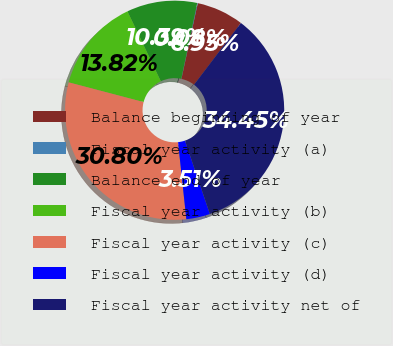Convert chart to OTSL. <chart><loc_0><loc_0><loc_500><loc_500><pie_chart><fcel>Balance beginning of year<fcel>Fiscal year activity (a)<fcel>Balance end of year<fcel>Fiscal year activity (b)<fcel>Fiscal year activity (c)<fcel>Fiscal year activity (d)<fcel>Fiscal year activity net of<nl><fcel>6.95%<fcel>0.08%<fcel>10.39%<fcel>13.82%<fcel>30.8%<fcel>3.51%<fcel>34.45%<nl></chart> 